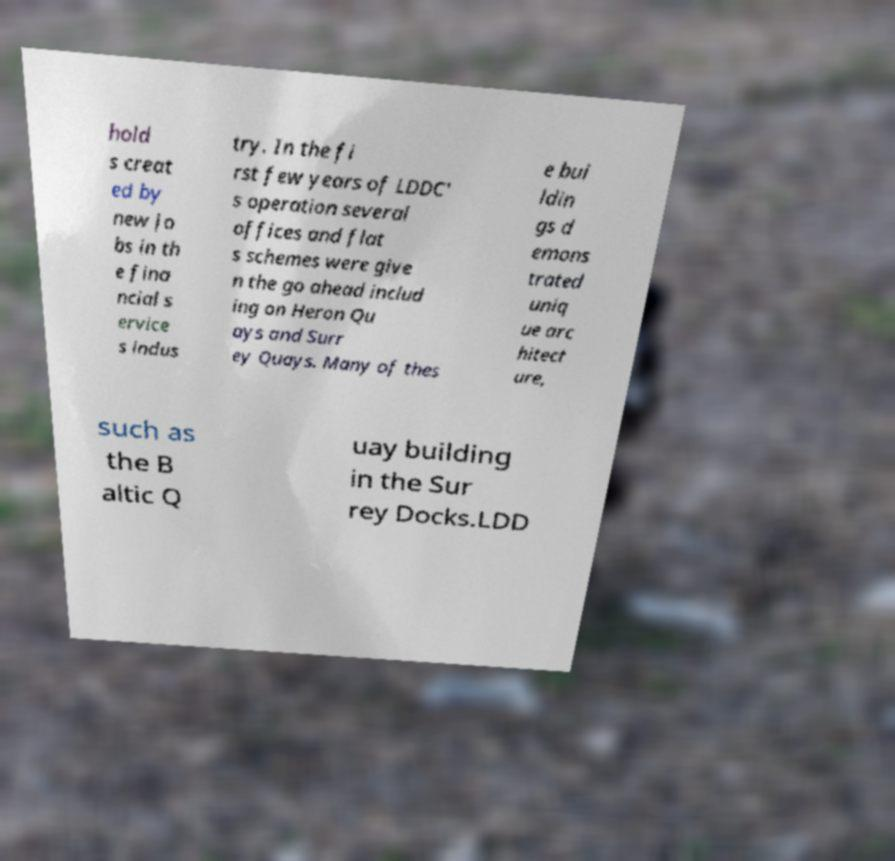Can you read and provide the text displayed in the image?This photo seems to have some interesting text. Can you extract and type it out for me? hold s creat ed by new jo bs in th e fina ncial s ervice s indus try. In the fi rst few years of LDDC' s operation several offices and flat s schemes were give n the go ahead includ ing on Heron Qu ays and Surr ey Quays. Many of thes e bui ldin gs d emons trated uniq ue arc hitect ure, such as the B altic Q uay building in the Sur rey Docks.LDD 